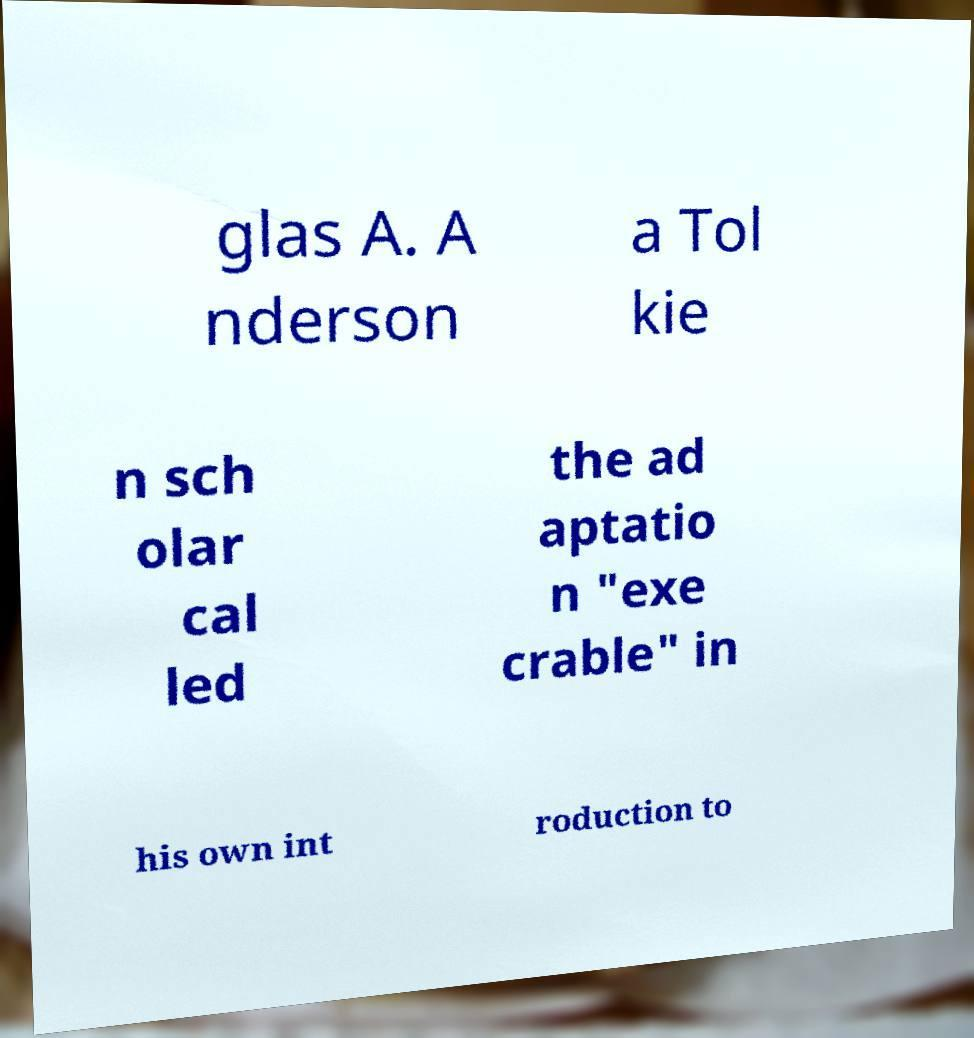Could you assist in decoding the text presented in this image and type it out clearly? glas A. A nderson a Tol kie n sch olar cal led the ad aptatio n "exe crable" in his own int roduction to 